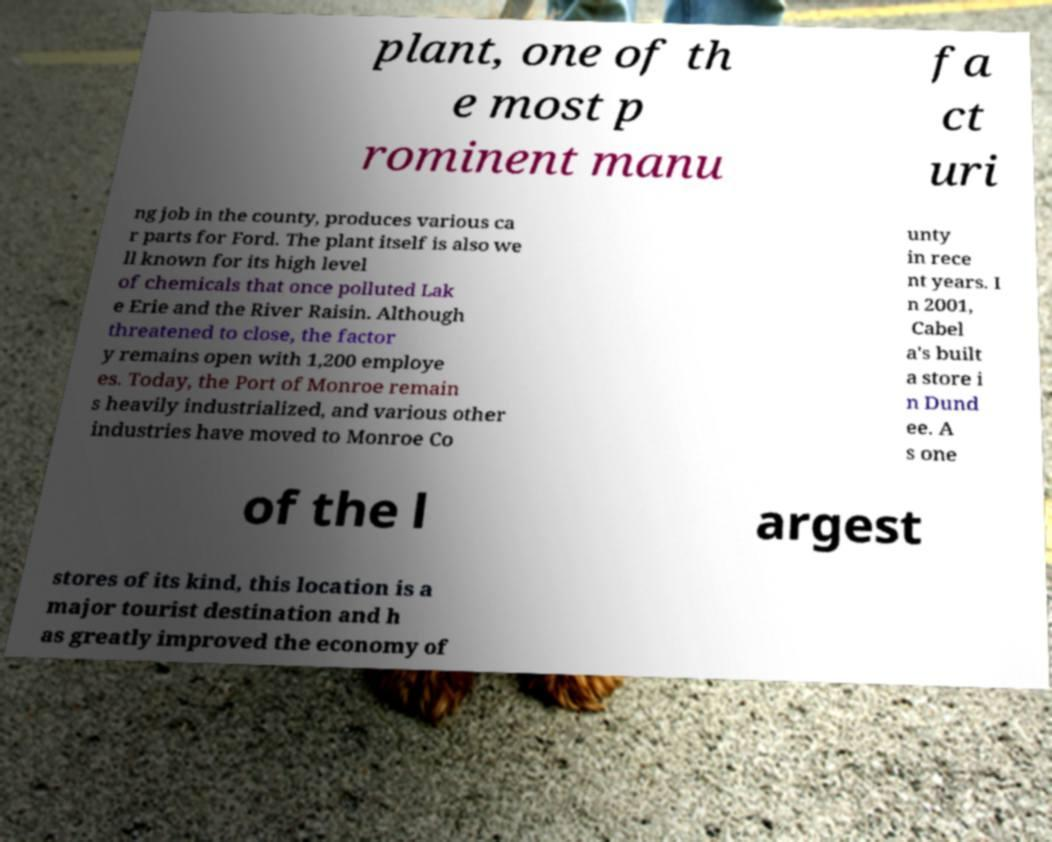I need the written content from this picture converted into text. Can you do that? plant, one of th e most p rominent manu fa ct uri ng job in the county, produces various ca r parts for Ford. The plant itself is also we ll known for its high level of chemicals that once polluted Lak e Erie and the River Raisin. Although threatened to close, the factor y remains open with 1,200 employe es. Today, the Port of Monroe remain s heavily industrialized, and various other industries have moved to Monroe Co unty in rece nt years. I n 2001, Cabel a's built a store i n Dund ee. A s one of the l argest stores of its kind, this location is a major tourist destination and h as greatly improved the economy of 